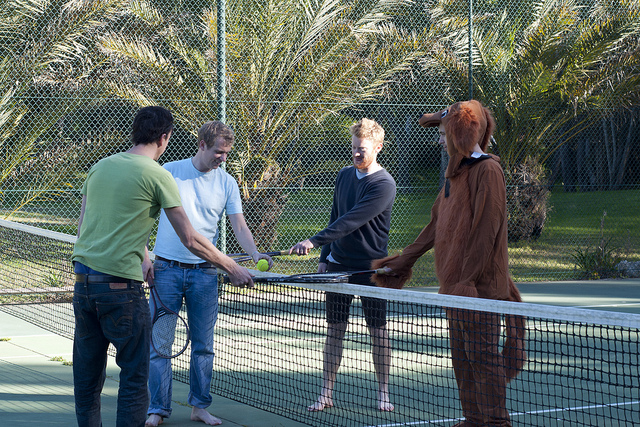Please provide a short description for this region: [0.11, 0.33, 0.39, 0.82]. A man in a green shirt is standing next to three other people. 